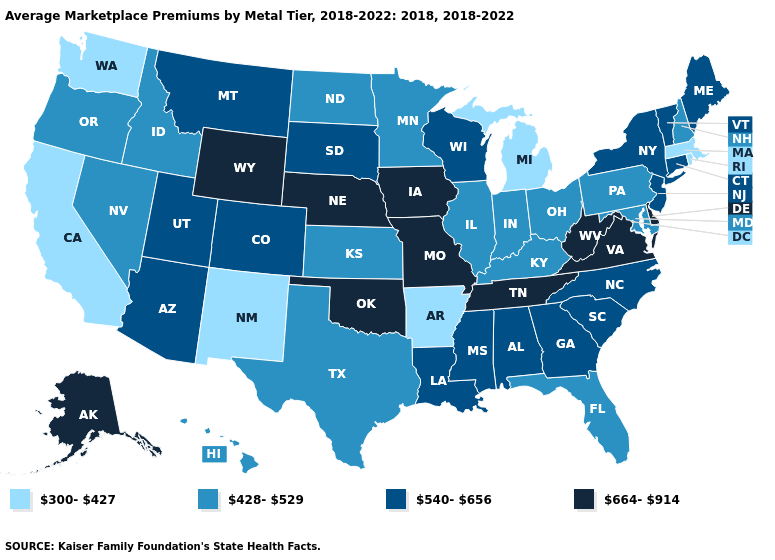Among the states that border Idaho , which have the highest value?
Be succinct. Wyoming. Does Utah have the lowest value in the West?
Concise answer only. No. Name the states that have a value in the range 664-914?
Write a very short answer. Alaska, Delaware, Iowa, Missouri, Nebraska, Oklahoma, Tennessee, Virginia, West Virginia, Wyoming. What is the value of North Dakota?
Short answer required. 428-529. Name the states that have a value in the range 664-914?
Answer briefly. Alaska, Delaware, Iowa, Missouri, Nebraska, Oklahoma, Tennessee, Virginia, West Virginia, Wyoming. What is the highest value in the MidWest ?
Write a very short answer. 664-914. Which states hav the highest value in the West?
Write a very short answer. Alaska, Wyoming. Does the map have missing data?
Answer briefly. No. What is the highest value in the USA?
Be succinct. 664-914. Does Missouri have the highest value in the MidWest?
Short answer required. Yes. Name the states that have a value in the range 664-914?
Concise answer only. Alaska, Delaware, Iowa, Missouri, Nebraska, Oklahoma, Tennessee, Virginia, West Virginia, Wyoming. Does Massachusetts have the same value as Washington?
Short answer required. Yes. Does the map have missing data?
Give a very brief answer. No. Among the states that border Vermont , does Massachusetts have the lowest value?
Short answer required. Yes. Which states have the lowest value in the USA?
Keep it brief. Arkansas, California, Massachusetts, Michigan, New Mexico, Rhode Island, Washington. 